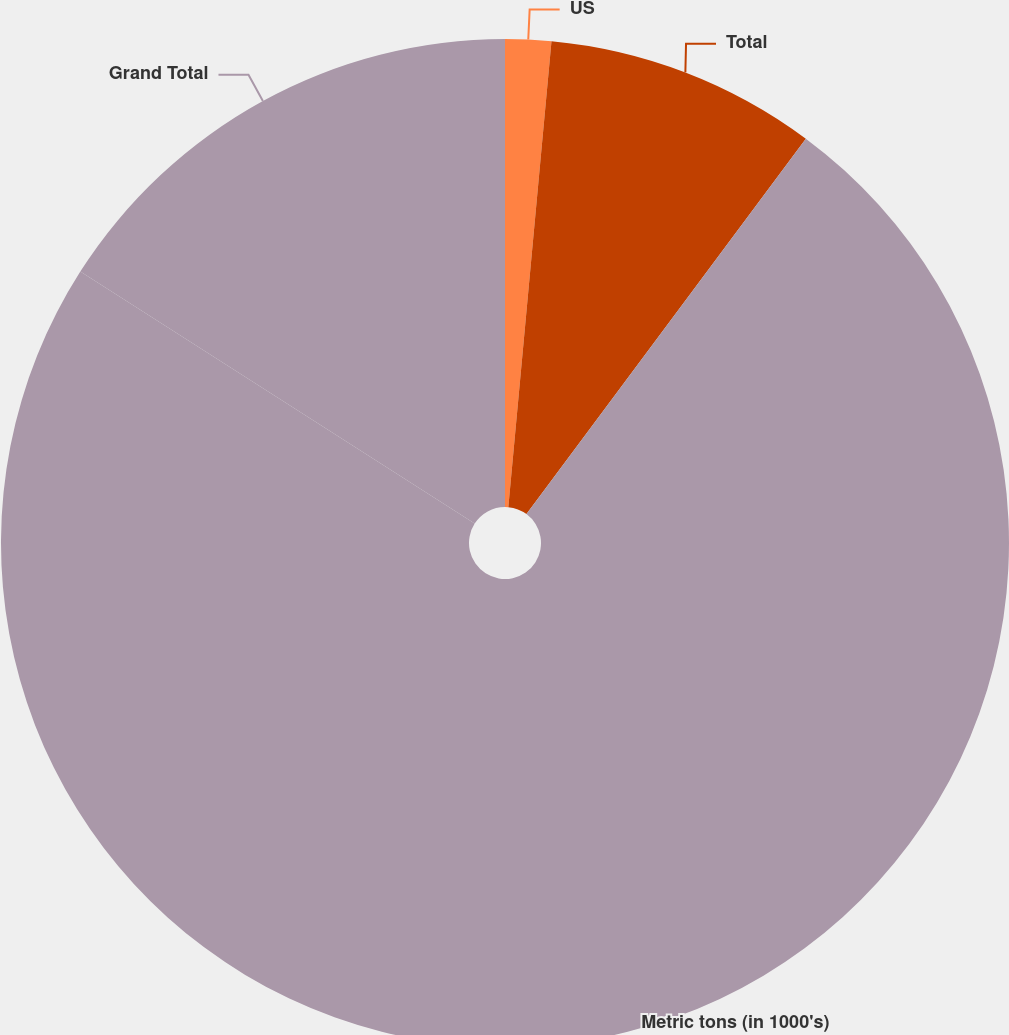Convert chart to OTSL. <chart><loc_0><loc_0><loc_500><loc_500><pie_chart><fcel>US<fcel>Total<fcel>Metric tons (in 1000's)<fcel>Grand Total<nl><fcel>1.47%<fcel>8.71%<fcel>73.87%<fcel>15.95%<nl></chart> 